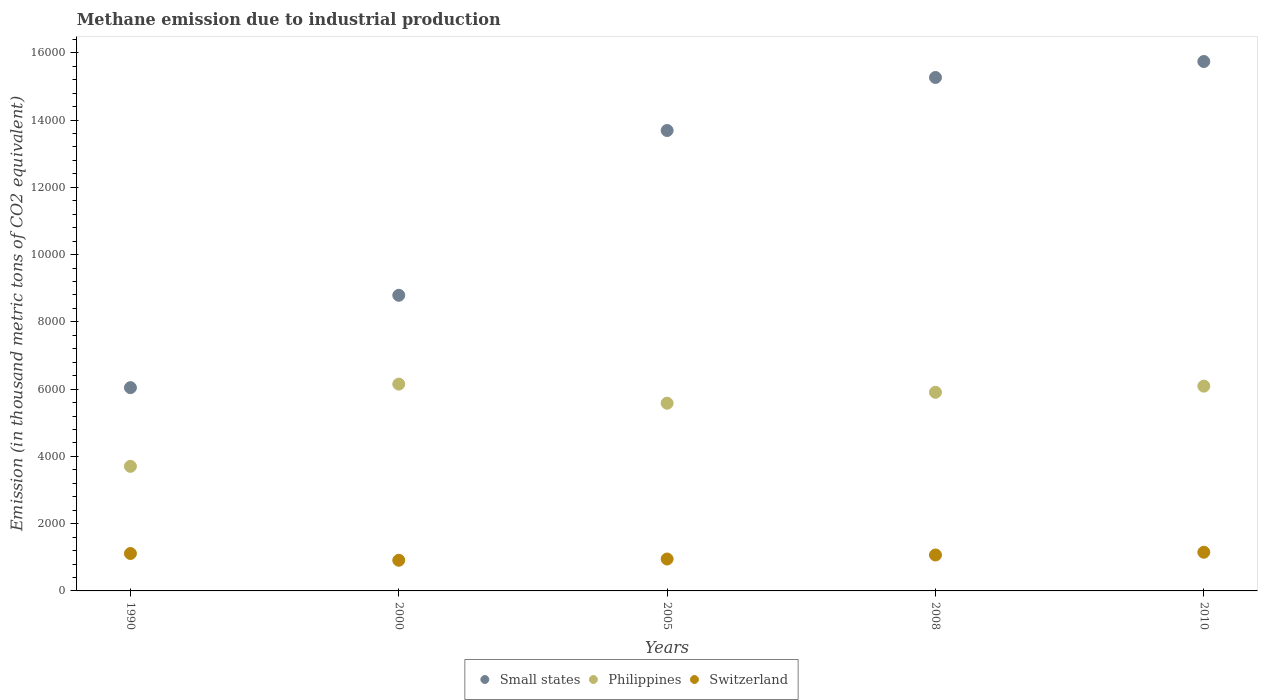Is the number of dotlines equal to the number of legend labels?
Offer a terse response. Yes. What is the amount of methane emitted in Switzerland in 2005?
Offer a very short reply. 948.6. Across all years, what is the maximum amount of methane emitted in Switzerland?
Your response must be concise. 1150.2. Across all years, what is the minimum amount of methane emitted in Philippines?
Provide a succinct answer. 3704.2. What is the total amount of methane emitted in Philippines in the graph?
Make the answer very short. 2.74e+04. What is the difference between the amount of methane emitted in Switzerland in 2005 and that in 2010?
Ensure brevity in your answer.  -201.6. What is the difference between the amount of methane emitted in Philippines in 1990 and the amount of methane emitted in Switzerland in 2000?
Offer a very short reply. 2792.6. What is the average amount of methane emitted in Small states per year?
Ensure brevity in your answer.  1.19e+04. In the year 1990, what is the difference between the amount of methane emitted in Small states and amount of methane emitted in Philippines?
Provide a succinct answer. 2339.4. In how many years, is the amount of methane emitted in Philippines greater than 2800 thousand metric tons?
Make the answer very short. 5. What is the ratio of the amount of methane emitted in Philippines in 2008 to that in 2010?
Provide a short and direct response. 0.97. What is the difference between the highest and the second highest amount of methane emitted in Philippines?
Offer a very short reply. 60.3. What is the difference between the highest and the lowest amount of methane emitted in Small states?
Make the answer very short. 9696.7. Is the amount of methane emitted in Switzerland strictly greater than the amount of methane emitted in Philippines over the years?
Your answer should be compact. No. Is the amount of methane emitted in Small states strictly less than the amount of methane emitted in Philippines over the years?
Provide a succinct answer. No. How many years are there in the graph?
Provide a succinct answer. 5. Are the values on the major ticks of Y-axis written in scientific E-notation?
Make the answer very short. No. How many legend labels are there?
Your response must be concise. 3. What is the title of the graph?
Offer a very short reply. Methane emission due to industrial production. What is the label or title of the Y-axis?
Offer a very short reply. Emission (in thousand metric tons of CO2 equivalent). What is the Emission (in thousand metric tons of CO2 equivalent) in Small states in 1990?
Offer a very short reply. 6043.6. What is the Emission (in thousand metric tons of CO2 equivalent) of Philippines in 1990?
Offer a very short reply. 3704.2. What is the Emission (in thousand metric tons of CO2 equivalent) of Switzerland in 1990?
Provide a succinct answer. 1112.7. What is the Emission (in thousand metric tons of CO2 equivalent) of Small states in 2000?
Keep it short and to the point. 8790. What is the Emission (in thousand metric tons of CO2 equivalent) of Philippines in 2000?
Offer a very short reply. 6149.1. What is the Emission (in thousand metric tons of CO2 equivalent) in Switzerland in 2000?
Ensure brevity in your answer.  911.6. What is the Emission (in thousand metric tons of CO2 equivalent) in Small states in 2005?
Your answer should be compact. 1.37e+04. What is the Emission (in thousand metric tons of CO2 equivalent) of Philippines in 2005?
Provide a short and direct response. 5580.9. What is the Emission (in thousand metric tons of CO2 equivalent) in Switzerland in 2005?
Ensure brevity in your answer.  948.6. What is the Emission (in thousand metric tons of CO2 equivalent) of Small states in 2008?
Provide a short and direct response. 1.53e+04. What is the Emission (in thousand metric tons of CO2 equivalent) of Philippines in 2008?
Ensure brevity in your answer.  5905.9. What is the Emission (in thousand metric tons of CO2 equivalent) of Switzerland in 2008?
Provide a short and direct response. 1068.1. What is the Emission (in thousand metric tons of CO2 equivalent) in Small states in 2010?
Your answer should be very brief. 1.57e+04. What is the Emission (in thousand metric tons of CO2 equivalent) of Philippines in 2010?
Offer a terse response. 6088.8. What is the Emission (in thousand metric tons of CO2 equivalent) of Switzerland in 2010?
Your response must be concise. 1150.2. Across all years, what is the maximum Emission (in thousand metric tons of CO2 equivalent) in Small states?
Provide a succinct answer. 1.57e+04. Across all years, what is the maximum Emission (in thousand metric tons of CO2 equivalent) of Philippines?
Your answer should be compact. 6149.1. Across all years, what is the maximum Emission (in thousand metric tons of CO2 equivalent) in Switzerland?
Provide a succinct answer. 1150.2. Across all years, what is the minimum Emission (in thousand metric tons of CO2 equivalent) of Small states?
Your answer should be compact. 6043.6. Across all years, what is the minimum Emission (in thousand metric tons of CO2 equivalent) in Philippines?
Your answer should be very brief. 3704.2. Across all years, what is the minimum Emission (in thousand metric tons of CO2 equivalent) of Switzerland?
Offer a very short reply. 911.6. What is the total Emission (in thousand metric tons of CO2 equivalent) in Small states in the graph?
Provide a short and direct response. 5.95e+04. What is the total Emission (in thousand metric tons of CO2 equivalent) in Philippines in the graph?
Provide a short and direct response. 2.74e+04. What is the total Emission (in thousand metric tons of CO2 equivalent) of Switzerland in the graph?
Ensure brevity in your answer.  5191.2. What is the difference between the Emission (in thousand metric tons of CO2 equivalent) of Small states in 1990 and that in 2000?
Your answer should be compact. -2746.4. What is the difference between the Emission (in thousand metric tons of CO2 equivalent) in Philippines in 1990 and that in 2000?
Make the answer very short. -2444.9. What is the difference between the Emission (in thousand metric tons of CO2 equivalent) in Switzerland in 1990 and that in 2000?
Offer a very short reply. 201.1. What is the difference between the Emission (in thousand metric tons of CO2 equivalent) of Small states in 1990 and that in 2005?
Offer a very short reply. -7645.8. What is the difference between the Emission (in thousand metric tons of CO2 equivalent) of Philippines in 1990 and that in 2005?
Keep it short and to the point. -1876.7. What is the difference between the Emission (in thousand metric tons of CO2 equivalent) in Switzerland in 1990 and that in 2005?
Your response must be concise. 164.1. What is the difference between the Emission (in thousand metric tons of CO2 equivalent) of Small states in 1990 and that in 2008?
Your response must be concise. -9221.9. What is the difference between the Emission (in thousand metric tons of CO2 equivalent) in Philippines in 1990 and that in 2008?
Your answer should be compact. -2201.7. What is the difference between the Emission (in thousand metric tons of CO2 equivalent) of Switzerland in 1990 and that in 2008?
Your answer should be compact. 44.6. What is the difference between the Emission (in thousand metric tons of CO2 equivalent) in Small states in 1990 and that in 2010?
Keep it short and to the point. -9696.7. What is the difference between the Emission (in thousand metric tons of CO2 equivalent) in Philippines in 1990 and that in 2010?
Offer a terse response. -2384.6. What is the difference between the Emission (in thousand metric tons of CO2 equivalent) of Switzerland in 1990 and that in 2010?
Provide a short and direct response. -37.5. What is the difference between the Emission (in thousand metric tons of CO2 equivalent) in Small states in 2000 and that in 2005?
Offer a very short reply. -4899.4. What is the difference between the Emission (in thousand metric tons of CO2 equivalent) in Philippines in 2000 and that in 2005?
Give a very brief answer. 568.2. What is the difference between the Emission (in thousand metric tons of CO2 equivalent) of Switzerland in 2000 and that in 2005?
Your answer should be compact. -37. What is the difference between the Emission (in thousand metric tons of CO2 equivalent) in Small states in 2000 and that in 2008?
Keep it short and to the point. -6475.5. What is the difference between the Emission (in thousand metric tons of CO2 equivalent) in Philippines in 2000 and that in 2008?
Ensure brevity in your answer.  243.2. What is the difference between the Emission (in thousand metric tons of CO2 equivalent) of Switzerland in 2000 and that in 2008?
Your response must be concise. -156.5. What is the difference between the Emission (in thousand metric tons of CO2 equivalent) in Small states in 2000 and that in 2010?
Ensure brevity in your answer.  -6950.3. What is the difference between the Emission (in thousand metric tons of CO2 equivalent) in Philippines in 2000 and that in 2010?
Provide a succinct answer. 60.3. What is the difference between the Emission (in thousand metric tons of CO2 equivalent) of Switzerland in 2000 and that in 2010?
Keep it short and to the point. -238.6. What is the difference between the Emission (in thousand metric tons of CO2 equivalent) in Small states in 2005 and that in 2008?
Offer a very short reply. -1576.1. What is the difference between the Emission (in thousand metric tons of CO2 equivalent) in Philippines in 2005 and that in 2008?
Offer a terse response. -325. What is the difference between the Emission (in thousand metric tons of CO2 equivalent) in Switzerland in 2005 and that in 2008?
Provide a succinct answer. -119.5. What is the difference between the Emission (in thousand metric tons of CO2 equivalent) in Small states in 2005 and that in 2010?
Keep it short and to the point. -2050.9. What is the difference between the Emission (in thousand metric tons of CO2 equivalent) in Philippines in 2005 and that in 2010?
Ensure brevity in your answer.  -507.9. What is the difference between the Emission (in thousand metric tons of CO2 equivalent) of Switzerland in 2005 and that in 2010?
Your answer should be compact. -201.6. What is the difference between the Emission (in thousand metric tons of CO2 equivalent) of Small states in 2008 and that in 2010?
Your answer should be compact. -474.8. What is the difference between the Emission (in thousand metric tons of CO2 equivalent) of Philippines in 2008 and that in 2010?
Make the answer very short. -182.9. What is the difference between the Emission (in thousand metric tons of CO2 equivalent) in Switzerland in 2008 and that in 2010?
Offer a very short reply. -82.1. What is the difference between the Emission (in thousand metric tons of CO2 equivalent) in Small states in 1990 and the Emission (in thousand metric tons of CO2 equivalent) in Philippines in 2000?
Ensure brevity in your answer.  -105.5. What is the difference between the Emission (in thousand metric tons of CO2 equivalent) of Small states in 1990 and the Emission (in thousand metric tons of CO2 equivalent) of Switzerland in 2000?
Your answer should be very brief. 5132. What is the difference between the Emission (in thousand metric tons of CO2 equivalent) in Philippines in 1990 and the Emission (in thousand metric tons of CO2 equivalent) in Switzerland in 2000?
Your response must be concise. 2792.6. What is the difference between the Emission (in thousand metric tons of CO2 equivalent) in Small states in 1990 and the Emission (in thousand metric tons of CO2 equivalent) in Philippines in 2005?
Keep it short and to the point. 462.7. What is the difference between the Emission (in thousand metric tons of CO2 equivalent) of Small states in 1990 and the Emission (in thousand metric tons of CO2 equivalent) of Switzerland in 2005?
Give a very brief answer. 5095. What is the difference between the Emission (in thousand metric tons of CO2 equivalent) of Philippines in 1990 and the Emission (in thousand metric tons of CO2 equivalent) of Switzerland in 2005?
Provide a succinct answer. 2755.6. What is the difference between the Emission (in thousand metric tons of CO2 equivalent) in Small states in 1990 and the Emission (in thousand metric tons of CO2 equivalent) in Philippines in 2008?
Offer a terse response. 137.7. What is the difference between the Emission (in thousand metric tons of CO2 equivalent) of Small states in 1990 and the Emission (in thousand metric tons of CO2 equivalent) of Switzerland in 2008?
Keep it short and to the point. 4975.5. What is the difference between the Emission (in thousand metric tons of CO2 equivalent) of Philippines in 1990 and the Emission (in thousand metric tons of CO2 equivalent) of Switzerland in 2008?
Make the answer very short. 2636.1. What is the difference between the Emission (in thousand metric tons of CO2 equivalent) of Small states in 1990 and the Emission (in thousand metric tons of CO2 equivalent) of Philippines in 2010?
Offer a terse response. -45.2. What is the difference between the Emission (in thousand metric tons of CO2 equivalent) of Small states in 1990 and the Emission (in thousand metric tons of CO2 equivalent) of Switzerland in 2010?
Make the answer very short. 4893.4. What is the difference between the Emission (in thousand metric tons of CO2 equivalent) of Philippines in 1990 and the Emission (in thousand metric tons of CO2 equivalent) of Switzerland in 2010?
Make the answer very short. 2554. What is the difference between the Emission (in thousand metric tons of CO2 equivalent) of Small states in 2000 and the Emission (in thousand metric tons of CO2 equivalent) of Philippines in 2005?
Your answer should be compact. 3209.1. What is the difference between the Emission (in thousand metric tons of CO2 equivalent) in Small states in 2000 and the Emission (in thousand metric tons of CO2 equivalent) in Switzerland in 2005?
Your answer should be compact. 7841.4. What is the difference between the Emission (in thousand metric tons of CO2 equivalent) of Philippines in 2000 and the Emission (in thousand metric tons of CO2 equivalent) of Switzerland in 2005?
Provide a succinct answer. 5200.5. What is the difference between the Emission (in thousand metric tons of CO2 equivalent) in Small states in 2000 and the Emission (in thousand metric tons of CO2 equivalent) in Philippines in 2008?
Your response must be concise. 2884.1. What is the difference between the Emission (in thousand metric tons of CO2 equivalent) of Small states in 2000 and the Emission (in thousand metric tons of CO2 equivalent) of Switzerland in 2008?
Provide a succinct answer. 7721.9. What is the difference between the Emission (in thousand metric tons of CO2 equivalent) of Philippines in 2000 and the Emission (in thousand metric tons of CO2 equivalent) of Switzerland in 2008?
Give a very brief answer. 5081. What is the difference between the Emission (in thousand metric tons of CO2 equivalent) of Small states in 2000 and the Emission (in thousand metric tons of CO2 equivalent) of Philippines in 2010?
Keep it short and to the point. 2701.2. What is the difference between the Emission (in thousand metric tons of CO2 equivalent) in Small states in 2000 and the Emission (in thousand metric tons of CO2 equivalent) in Switzerland in 2010?
Provide a succinct answer. 7639.8. What is the difference between the Emission (in thousand metric tons of CO2 equivalent) in Philippines in 2000 and the Emission (in thousand metric tons of CO2 equivalent) in Switzerland in 2010?
Offer a terse response. 4998.9. What is the difference between the Emission (in thousand metric tons of CO2 equivalent) in Small states in 2005 and the Emission (in thousand metric tons of CO2 equivalent) in Philippines in 2008?
Offer a terse response. 7783.5. What is the difference between the Emission (in thousand metric tons of CO2 equivalent) of Small states in 2005 and the Emission (in thousand metric tons of CO2 equivalent) of Switzerland in 2008?
Keep it short and to the point. 1.26e+04. What is the difference between the Emission (in thousand metric tons of CO2 equivalent) in Philippines in 2005 and the Emission (in thousand metric tons of CO2 equivalent) in Switzerland in 2008?
Make the answer very short. 4512.8. What is the difference between the Emission (in thousand metric tons of CO2 equivalent) in Small states in 2005 and the Emission (in thousand metric tons of CO2 equivalent) in Philippines in 2010?
Your answer should be very brief. 7600.6. What is the difference between the Emission (in thousand metric tons of CO2 equivalent) in Small states in 2005 and the Emission (in thousand metric tons of CO2 equivalent) in Switzerland in 2010?
Your answer should be compact. 1.25e+04. What is the difference between the Emission (in thousand metric tons of CO2 equivalent) in Philippines in 2005 and the Emission (in thousand metric tons of CO2 equivalent) in Switzerland in 2010?
Provide a short and direct response. 4430.7. What is the difference between the Emission (in thousand metric tons of CO2 equivalent) of Small states in 2008 and the Emission (in thousand metric tons of CO2 equivalent) of Philippines in 2010?
Your response must be concise. 9176.7. What is the difference between the Emission (in thousand metric tons of CO2 equivalent) in Small states in 2008 and the Emission (in thousand metric tons of CO2 equivalent) in Switzerland in 2010?
Keep it short and to the point. 1.41e+04. What is the difference between the Emission (in thousand metric tons of CO2 equivalent) of Philippines in 2008 and the Emission (in thousand metric tons of CO2 equivalent) of Switzerland in 2010?
Your response must be concise. 4755.7. What is the average Emission (in thousand metric tons of CO2 equivalent) of Small states per year?
Give a very brief answer. 1.19e+04. What is the average Emission (in thousand metric tons of CO2 equivalent) in Philippines per year?
Ensure brevity in your answer.  5485.78. What is the average Emission (in thousand metric tons of CO2 equivalent) in Switzerland per year?
Provide a succinct answer. 1038.24. In the year 1990, what is the difference between the Emission (in thousand metric tons of CO2 equivalent) of Small states and Emission (in thousand metric tons of CO2 equivalent) of Philippines?
Your answer should be very brief. 2339.4. In the year 1990, what is the difference between the Emission (in thousand metric tons of CO2 equivalent) of Small states and Emission (in thousand metric tons of CO2 equivalent) of Switzerland?
Give a very brief answer. 4930.9. In the year 1990, what is the difference between the Emission (in thousand metric tons of CO2 equivalent) of Philippines and Emission (in thousand metric tons of CO2 equivalent) of Switzerland?
Keep it short and to the point. 2591.5. In the year 2000, what is the difference between the Emission (in thousand metric tons of CO2 equivalent) in Small states and Emission (in thousand metric tons of CO2 equivalent) in Philippines?
Keep it short and to the point. 2640.9. In the year 2000, what is the difference between the Emission (in thousand metric tons of CO2 equivalent) of Small states and Emission (in thousand metric tons of CO2 equivalent) of Switzerland?
Your answer should be compact. 7878.4. In the year 2000, what is the difference between the Emission (in thousand metric tons of CO2 equivalent) of Philippines and Emission (in thousand metric tons of CO2 equivalent) of Switzerland?
Offer a very short reply. 5237.5. In the year 2005, what is the difference between the Emission (in thousand metric tons of CO2 equivalent) in Small states and Emission (in thousand metric tons of CO2 equivalent) in Philippines?
Your response must be concise. 8108.5. In the year 2005, what is the difference between the Emission (in thousand metric tons of CO2 equivalent) in Small states and Emission (in thousand metric tons of CO2 equivalent) in Switzerland?
Provide a short and direct response. 1.27e+04. In the year 2005, what is the difference between the Emission (in thousand metric tons of CO2 equivalent) in Philippines and Emission (in thousand metric tons of CO2 equivalent) in Switzerland?
Ensure brevity in your answer.  4632.3. In the year 2008, what is the difference between the Emission (in thousand metric tons of CO2 equivalent) in Small states and Emission (in thousand metric tons of CO2 equivalent) in Philippines?
Ensure brevity in your answer.  9359.6. In the year 2008, what is the difference between the Emission (in thousand metric tons of CO2 equivalent) of Small states and Emission (in thousand metric tons of CO2 equivalent) of Switzerland?
Ensure brevity in your answer.  1.42e+04. In the year 2008, what is the difference between the Emission (in thousand metric tons of CO2 equivalent) of Philippines and Emission (in thousand metric tons of CO2 equivalent) of Switzerland?
Provide a succinct answer. 4837.8. In the year 2010, what is the difference between the Emission (in thousand metric tons of CO2 equivalent) in Small states and Emission (in thousand metric tons of CO2 equivalent) in Philippines?
Keep it short and to the point. 9651.5. In the year 2010, what is the difference between the Emission (in thousand metric tons of CO2 equivalent) of Small states and Emission (in thousand metric tons of CO2 equivalent) of Switzerland?
Your response must be concise. 1.46e+04. In the year 2010, what is the difference between the Emission (in thousand metric tons of CO2 equivalent) of Philippines and Emission (in thousand metric tons of CO2 equivalent) of Switzerland?
Keep it short and to the point. 4938.6. What is the ratio of the Emission (in thousand metric tons of CO2 equivalent) of Small states in 1990 to that in 2000?
Your response must be concise. 0.69. What is the ratio of the Emission (in thousand metric tons of CO2 equivalent) of Philippines in 1990 to that in 2000?
Provide a short and direct response. 0.6. What is the ratio of the Emission (in thousand metric tons of CO2 equivalent) in Switzerland in 1990 to that in 2000?
Your response must be concise. 1.22. What is the ratio of the Emission (in thousand metric tons of CO2 equivalent) of Small states in 1990 to that in 2005?
Provide a short and direct response. 0.44. What is the ratio of the Emission (in thousand metric tons of CO2 equivalent) of Philippines in 1990 to that in 2005?
Your answer should be compact. 0.66. What is the ratio of the Emission (in thousand metric tons of CO2 equivalent) of Switzerland in 1990 to that in 2005?
Keep it short and to the point. 1.17. What is the ratio of the Emission (in thousand metric tons of CO2 equivalent) in Small states in 1990 to that in 2008?
Your response must be concise. 0.4. What is the ratio of the Emission (in thousand metric tons of CO2 equivalent) of Philippines in 1990 to that in 2008?
Provide a short and direct response. 0.63. What is the ratio of the Emission (in thousand metric tons of CO2 equivalent) in Switzerland in 1990 to that in 2008?
Provide a short and direct response. 1.04. What is the ratio of the Emission (in thousand metric tons of CO2 equivalent) of Small states in 1990 to that in 2010?
Keep it short and to the point. 0.38. What is the ratio of the Emission (in thousand metric tons of CO2 equivalent) in Philippines in 1990 to that in 2010?
Offer a terse response. 0.61. What is the ratio of the Emission (in thousand metric tons of CO2 equivalent) of Switzerland in 1990 to that in 2010?
Provide a short and direct response. 0.97. What is the ratio of the Emission (in thousand metric tons of CO2 equivalent) of Small states in 2000 to that in 2005?
Offer a very short reply. 0.64. What is the ratio of the Emission (in thousand metric tons of CO2 equivalent) in Philippines in 2000 to that in 2005?
Ensure brevity in your answer.  1.1. What is the ratio of the Emission (in thousand metric tons of CO2 equivalent) of Switzerland in 2000 to that in 2005?
Your answer should be compact. 0.96. What is the ratio of the Emission (in thousand metric tons of CO2 equivalent) of Small states in 2000 to that in 2008?
Your response must be concise. 0.58. What is the ratio of the Emission (in thousand metric tons of CO2 equivalent) of Philippines in 2000 to that in 2008?
Offer a terse response. 1.04. What is the ratio of the Emission (in thousand metric tons of CO2 equivalent) of Switzerland in 2000 to that in 2008?
Your answer should be very brief. 0.85. What is the ratio of the Emission (in thousand metric tons of CO2 equivalent) in Small states in 2000 to that in 2010?
Ensure brevity in your answer.  0.56. What is the ratio of the Emission (in thousand metric tons of CO2 equivalent) in Philippines in 2000 to that in 2010?
Provide a short and direct response. 1.01. What is the ratio of the Emission (in thousand metric tons of CO2 equivalent) in Switzerland in 2000 to that in 2010?
Offer a very short reply. 0.79. What is the ratio of the Emission (in thousand metric tons of CO2 equivalent) of Small states in 2005 to that in 2008?
Keep it short and to the point. 0.9. What is the ratio of the Emission (in thousand metric tons of CO2 equivalent) of Philippines in 2005 to that in 2008?
Make the answer very short. 0.94. What is the ratio of the Emission (in thousand metric tons of CO2 equivalent) of Switzerland in 2005 to that in 2008?
Offer a very short reply. 0.89. What is the ratio of the Emission (in thousand metric tons of CO2 equivalent) in Small states in 2005 to that in 2010?
Offer a terse response. 0.87. What is the ratio of the Emission (in thousand metric tons of CO2 equivalent) in Philippines in 2005 to that in 2010?
Provide a succinct answer. 0.92. What is the ratio of the Emission (in thousand metric tons of CO2 equivalent) of Switzerland in 2005 to that in 2010?
Your answer should be very brief. 0.82. What is the ratio of the Emission (in thousand metric tons of CO2 equivalent) of Small states in 2008 to that in 2010?
Provide a succinct answer. 0.97. What is the ratio of the Emission (in thousand metric tons of CO2 equivalent) in Philippines in 2008 to that in 2010?
Make the answer very short. 0.97. What is the difference between the highest and the second highest Emission (in thousand metric tons of CO2 equivalent) in Small states?
Your answer should be compact. 474.8. What is the difference between the highest and the second highest Emission (in thousand metric tons of CO2 equivalent) in Philippines?
Provide a short and direct response. 60.3. What is the difference between the highest and the second highest Emission (in thousand metric tons of CO2 equivalent) of Switzerland?
Keep it short and to the point. 37.5. What is the difference between the highest and the lowest Emission (in thousand metric tons of CO2 equivalent) in Small states?
Ensure brevity in your answer.  9696.7. What is the difference between the highest and the lowest Emission (in thousand metric tons of CO2 equivalent) of Philippines?
Your response must be concise. 2444.9. What is the difference between the highest and the lowest Emission (in thousand metric tons of CO2 equivalent) of Switzerland?
Keep it short and to the point. 238.6. 